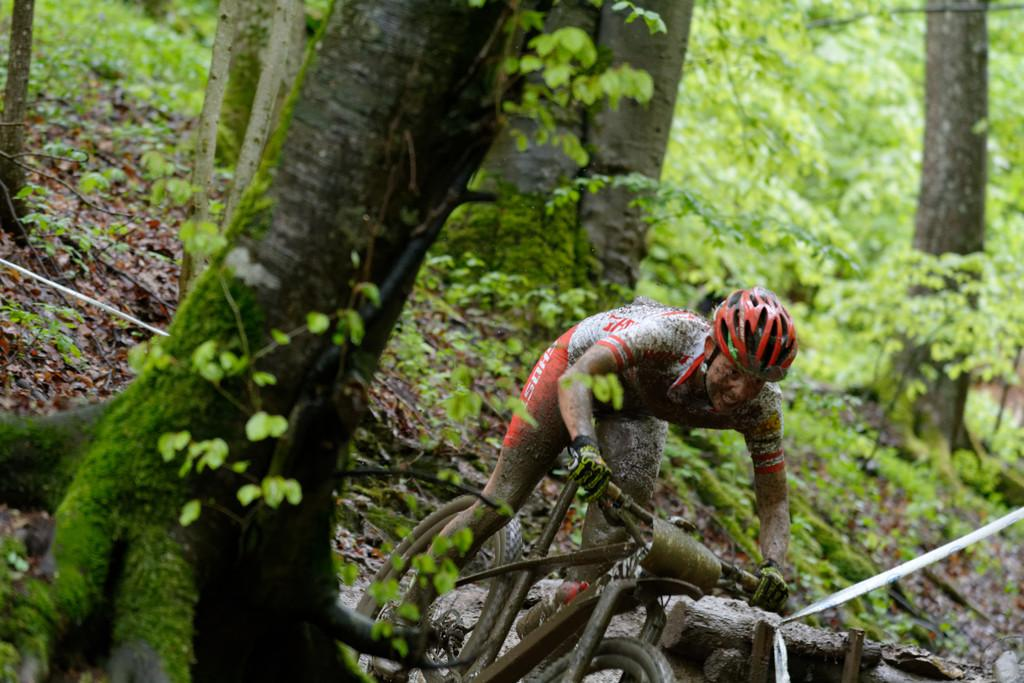What type of vegetation can be seen in the image? There are trees in the image. What is the man in the image doing? The man is riding a bicycle in the image. What safety precaution is the man taking while riding the bicycle? The man is wearing a helmet on his head. Can you tell me how many teeth the tree has in the image? Trees do not have teeth, so this question cannot be answered. What type of leg is the man using to ride the bicycle in the image? The man is using both of his legs to pedal the bicycle, but we cannot determine the specific type of leg from the image. 